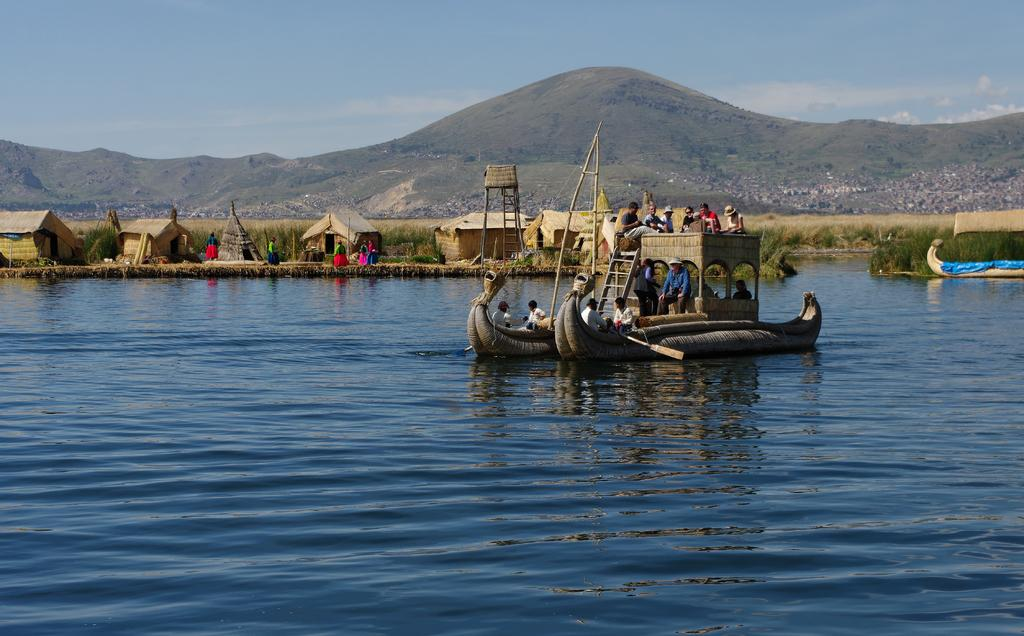What is the main subject in the center of the image? There is a person in the center of the image. What is the person interacting with in the center of the image? There is a ladder in the center of the image. What can be seen on the water in the image? There are boats on the river in the image. What type of structures can be seen in the background? In the background, there are huts. Are there any boats visible in the background? Yes, there is a boat visible in the background. What type of vegetation is present in the background? Plants are present in the background. What type of ground cover is visible in the background? Grass is visible in the background. What type of geographical feature can be seen in the background? There is a hill in the background. What is visible in the sky in the background? The sky is visible in the background. What type of weather can be inferred from the image? Clouds are present in the sky, suggesting a partly cloudy day. What type of soap is being used to clean the boats in the image? There is no soap present in the image, and no boats are being cleaned. 